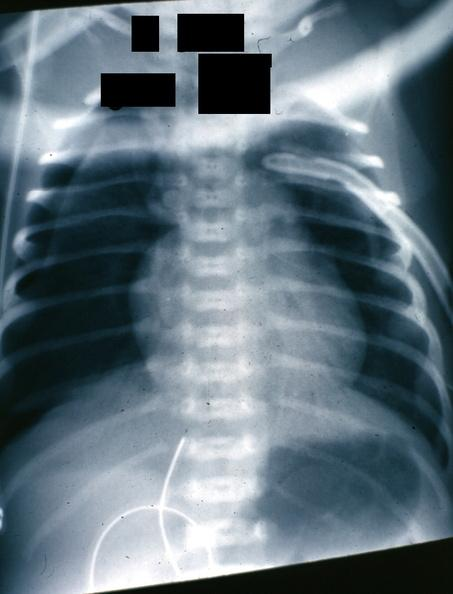where is this?
Answer the question using a single word or phrase. Lung 